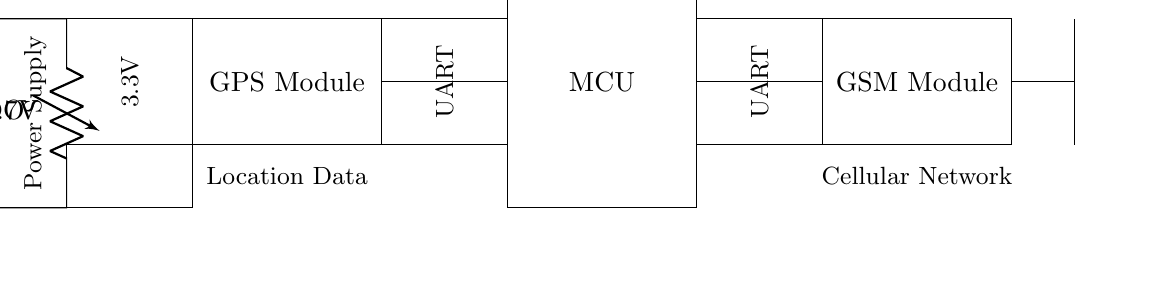What is the power supply voltage? The power supply provides a voltage of 3.7 volts as indicated on the battery symbol.
Answer: 3.7 volts What component is used for voltage regulation? The component providing voltage regulation is labeled as LDO in the circuit, which stands for Low Dropout Regulator.
Answer: LDO What does the MCU stand for? The abbreviation MCU stands for Microcontroller Unit, which is represented as a rectangular block in the diagram.
Answer: Microcontroller Unit Which module communicates with the cellular network? The GSM module is responsible for communication with the cellular network and it is specifically marked in the diagram.
Answer: GSM Module How many main components are depicted in the circuit? There are four main components visible: the power supply, GPS module, MCU, and GSM module. Each is represented distinctly in the circuit layout.
Answer: Four What type of data does the GPS module provide? The GPS module is responsible for providing location data, which is indicated in the diagram where it is connected with arrows.
Answer: Location Data Why is an antenna included in the circuit? The antenna is included to facilitate wireless communication with the GSM module, allowing it to send and receive signals effectively. This is necessary for tracking purposes.
Answer: Wireless communication 